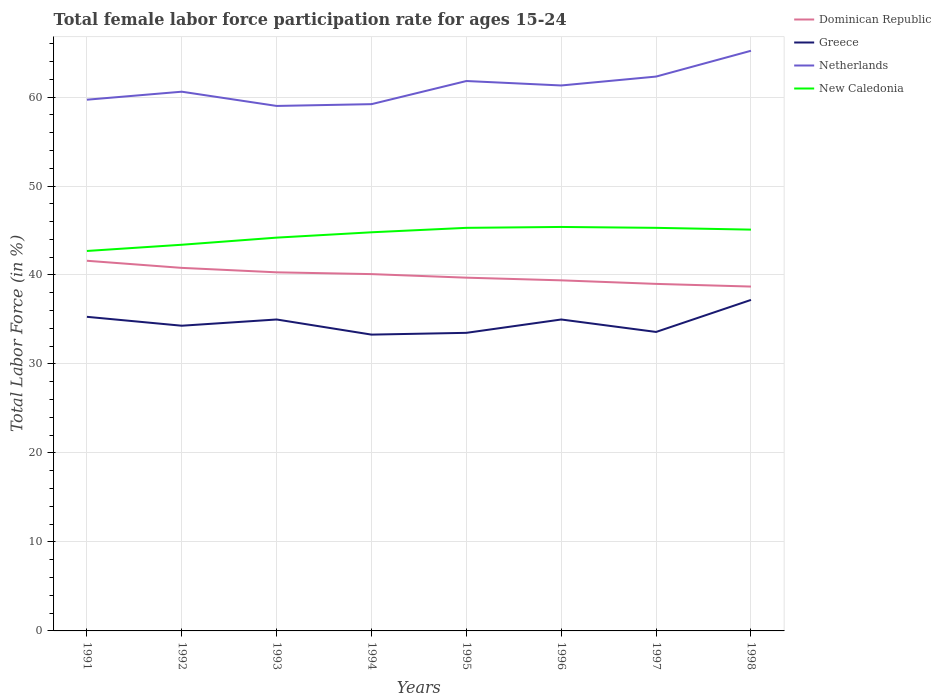How many different coloured lines are there?
Your answer should be very brief. 4. Does the line corresponding to New Caledonia intersect with the line corresponding to Netherlands?
Provide a short and direct response. No. Is the number of lines equal to the number of legend labels?
Provide a succinct answer. Yes. Across all years, what is the maximum female labor force participation rate in Greece?
Give a very brief answer. 33.3. In which year was the female labor force participation rate in New Caledonia maximum?
Give a very brief answer. 1991. What is the total female labor force participation rate in Greece in the graph?
Provide a succinct answer. -3.7. What is the difference between the highest and the second highest female labor force participation rate in Netherlands?
Your answer should be compact. 6.2. What is the difference between the highest and the lowest female labor force participation rate in New Caledonia?
Your answer should be compact. 5. Is the female labor force participation rate in Greece strictly greater than the female labor force participation rate in Netherlands over the years?
Give a very brief answer. Yes. How many lines are there?
Provide a succinct answer. 4. How many years are there in the graph?
Ensure brevity in your answer.  8. How many legend labels are there?
Your response must be concise. 4. How are the legend labels stacked?
Your answer should be compact. Vertical. What is the title of the graph?
Ensure brevity in your answer.  Total female labor force participation rate for ages 15-24. Does "Grenada" appear as one of the legend labels in the graph?
Your response must be concise. No. What is the Total Labor Force (in %) of Dominican Republic in 1991?
Your answer should be compact. 41.6. What is the Total Labor Force (in %) of Greece in 1991?
Keep it short and to the point. 35.3. What is the Total Labor Force (in %) in Netherlands in 1991?
Provide a succinct answer. 59.7. What is the Total Labor Force (in %) of New Caledonia in 1991?
Your response must be concise. 42.7. What is the Total Labor Force (in %) of Dominican Republic in 1992?
Your answer should be compact. 40.8. What is the Total Labor Force (in %) of Greece in 1992?
Offer a terse response. 34.3. What is the Total Labor Force (in %) in Netherlands in 1992?
Give a very brief answer. 60.6. What is the Total Labor Force (in %) in New Caledonia in 1992?
Your answer should be very brief. 43.4. What is the Total Labor Force (in %) of Dominican Republic in 1993?
Your response must be concise. 40.3. What is the Total Labor Force (in %) of Greece in 1993?
Give a very brief answer. 35. What is the Total Labor Force (in %) in Netherlands in 1993?
Provide a short and direct response. 59. What is the Total Labor Force (in %) in New Caledonia in 1993?
Provide a succinct answer. 44.2. What is the Total Labor Force (in %) in Dominican Republic in 1994?
Provide a short and direct response. 40.1. What is the Total Labor Force (in %) in Greece in 1994?
Ensure brevity in your answer.  33.3. What is the Total Labor Force (in %) in Netherlands in 1994?
Make the answer very short. 59.2. What is the Total Labor Force (in %) in New Caledonia in 1994?
Provide a succinct answer. 44.8. What is the Total Labor Force (in %) in Dominican Republic in 1995?
Your answer should be compact. 39.7. What is the Total Labor Force (in %) of Greece in 1995?
Offer a terse response. 33.5. What is the Total Labor Force (in %) in Netherlands in 1995?
Offer a very short reply. 61.8. What is the Total Labor Force (in %) in New Caledonia in 1995?
Your answer should be compact. 45.3. What is the Total Labor Force (in %) in Dominican Republic in 1996?
Provide a succinct answer. 39.4. What is the Total Labor Force (in %) of Greece in 1996?
Your answer should be very brief. 35. What is the Total Labor Force (in %) in Netherlands in 1996?
Offer a very short reply. 61.3. What is the Total Labor Force (in %) in New Caledonia in 1996?
Ensure brevity in your answer.  45.4. What is the Total Labor Force (in %) of Dominican Republic in 1997?
Offer a very short reply. 39. What is the Total Labor Force (in %) in Greece in 1997?
Ensure brevity in your answer.  33.6. What is the Total Labor Force (in %) of Netherlands in 1997?
Give a very brief answer. 62.3. What is the Total Labor Force (in %) of New Caledonia in 1997?
Ensure brevity in your answer.  45.3. What is the Total Labor Force (in %) of Dominican Republic in 1998?
Your response must be concise. 38.7. What is the Total Labor Force (in %) in Greece in 1998?
Make the answer very short. 37.2. What is the Total Labor Force (in %) in Netherlands in 1998?
Keep it short and to the point. 65.2. What is the Total Labor Force (in %) in New Caledonia in 1998?
Provide a short and direct response. 45.1. Across all years, what is the maximum Total Labor Force (in %) of Dominican Republic?
Your answer should be compact. 41.6. Across all years, what is the maximum Total Labor Force (in %) in Greece?
Provide a succinct answer. 37.2. Across all years, what is the maximum Total Labor Force (in %) in Netherlands?
Provide a short and direct response. 65.2. Across all years, what is the maximum Total Labor Force (in %) in New Caledonia?
Provide a short and direct response. 45.4. Across all years, what is the minimum Total Labor Force (in %) of Dominican Republic?
Give a very brief answer. 38.7. Across all years, what is the minimum Total Labor Force (in %) of Greece?
Ensure brevity in your answer.  33.3. Across all years, what is the minimum Total Labor Force (in %) of New Caledonia?
Keep it short and to the point. 42.7. What is the total Total Labor Force (in %) in Dominican Republic in the graph?
Provide a short and direct response. 319.6. What is the total Total Labor Force (in %) in Greece in the graph?
Give a very brief answer. 277.2. What is the total Total Labor Force (in %) in Netherlands in the graph?
Your answer should be compact. 489.1. What is the total Total Labor Force (in %) of New Caledonia in the graph?
Provide a short and direct response. 356.2. What is the difference between the Total Labor Force (in %) in New Caledonia in 1991 and that in 1992?
Your answer should be very brief. -0.7. What is the difference between the Total Labor Force (in %) of Dominican Republic in 1991 and that in 1993?
Your answer should be compact. 1.3. What is the difference between the Total Labor Force (in %) in Dominican Republic in 1991 and that in 1994?
Your answer should be very brief. 1.5. What is the difference between the Total Labor Force (in %) in Netherlands in 1991 and that in 1994?
Your response must be concise. 0.5. What is the difference between the Total Labor Force (in %) in Dominican Republic in 1991 and that in 1995?
Give a very brief answer. 1.9. What is the difference between the Total Labor Force (in %) of Dominican Republic in 1991 and that in 1997?
Provide a succinct answer. 2.6. What is the difference between the Total Labor Force (in %) of Dominican Republic in 1991 and that in 1998?
Ensure brevity in your answer.  2.9. What is the difference between the Total Labor Force (in %) in Greece in 1992 and that in 1994?
Your answer should be very brief. 1. What is the difference between the Total Labor Force (in %) in Netherlands in 1992 and that in 1994?
Make the answer very short. 1.4. What is the difference between the Total Labor Force (in %) in Dominican Republic in 1992 and that in 1995?
Make the answer very short. 1.1. What is the difference between the Total Labor Force (in %) in Netherlands in 1992 and that in 1995?
Offer a terse response. -1.2. What is the difference between the Total Labor Force (in %) in New Caledonia in 1992 and that in 1995?
Make the answer very short. -1.9. What is the difference between the Total Labor Force (in %) in Greece in 1992 and that in 1996?
Keep it short and to the point. -0.7. What is the difference between the Total Labor Force (in %) of New Caledonia in 1992 and that in 1996?
Your answer should be compact. -2. What is the difference between the Total Labor Force (in %) in Dominican Republic in 1992 and that in 1997?
Your response must be concise. 1.8. What is the difference between the Total Labor Force (in %) of Greece in 1992 and that in 1997?
Offer a very short reply. 0.7. What is the difference between the Total Labor Force (in %) of Netherlands in 1992 and that in 1997?
Offer a very short reply. -1.7. What is the difference between the Total Labor Force (in %) in New Caledonia in 1992 and that in 1997?
Your answer should be very brief. -1.9. What is the difference between the Total Labor Force (in %) in Dominican Republic in 1992 and that in 1998?
Provide a short and direct response. 2.1. What is the difference between the Total Labor Force (in %) of Greece in 1993 and that in 1994?
Your answer should be compact. 1.7. What is the difference between the Total Labor Force (in %) of New Caledonia in 1993 and that in 1994?
Provide a succinct answer. -0.6. What is the difference between the Total Labor Force (in %) in Dominican Republic in 1993 and that in 1995?
Provide a succinct answer. 0.6. What is the difference between the Total Labor Force (in %) of Netherlands in 1993 and that in 1995?
Give a very brief answer. -2.8. What is the difference between the Total Labor Force (in %) in New Caledonia in 1993 and that in 1995?
Offer a terse response. -1.1. What is the difference between the Total Labor Force (in %) of Greece in 1993 and that in 1997?
Your answer should be compact. 1.4. What is the difference between the Total Labor Force (in %) in Netherlands in 1993 and that in 1997?
Ensure brevity in your answer.  -3.3. What is the difference between the Total Labor Force (in %) in New Caledonia in 1993 and that in 1997?
Make the answer very short. -1.1. What is the difference between the Total Labor Force (in %) of New Caledonia in 1993 and that in 1998?
Your answer should be compact. -0.9. What is the difference between the Total Labor Force (in %) in Greece in 1994 and that in 1995?
Give a very brief answer. -0.2. What is the difference between the Total Labor Force (in %) in Greece in 1994 and that in 1996?
Your response must be concise. -1.7. What is the difference between the Total Labor Force (in %) in New Caledonia in 1994 and that in 1996?
Your answer should be compact. -0.6. What is the difference between the Total Labor Force (in %) in Greece in 1994 and that in 1997?
Your answer should be compact. -0.3. What is the difference between the Total Labor Force (in %) of New Caledonia in 1994 and that in 1997?
Your response must be concise. -0.5. What is the difference between the Total Labor Force (in %) of Greece in 1994 and that in 1998?
Make the answer very short. -3.9. What is the difference between the Total Labor Force (in %) in Netherlands in 1994 and that in 1998?
Keep it short and to the point. -6. What is the difference between the Total Labor Force (in %) in Greece in 1995 and that in 1996?
Provide a succinct answer. -1.5. What is the difference between the Total Labor Force (in %) of Dominican Republic in 1995 and that in 1997?
Your response must be concise. 0.7. What is the difference between the Total Labor Force (in %) in Netherlands in 1995 and that in 1997?
Your answer should be compact. -0.5. What is the difference between the Total Labor Force (in %) of New Caledonia in 1995 and that in 1997?
Give a very brief answer. 0. What is the difference between the Total Labor Force (in %) of New Caledonia in 1995 and that in 1998?
Offer a very short reply. 0.2. What is the difference between the Total Labor Force (in %) of Dominican Republic in 1996 and that in 1997?
Your answer should be very brief. 0.4. What is the difference between the Total Labor Force (in %) in Netherlands in 1996 and that in 1997?
Provide a succinct answer. -1. What is the difference between the Total Labor Force (in %) of Greece in 1996 and that in 1998?
Offer a terse response. -2.2. What is the difference between the Total Labor Force (in %) in Netherlands in 1996 and that in 1998?
Offer a very short reply. -3.9. What is the difference between the Total Labor Force (in %) of New Caledonia in 1996 and that in 1998?
Make the answer very short. 0.3. What is the difference between the Total Labor Force (in %) of Greece in 1997 and that in 1998?
Offer a terse response. -3.6. What is the difference between the Total Labor Force (in %) in Greece in 1991 and the Total Labor Force (in %) in Netherlands in 1992?
Your answer should be compact. -25.3. What is the difference between the Total Labor Force (in %) in Dominican Republic in 1991 and the Total Labor Force (in %) in Netherlands in 1993?
Your response must be concise. -17.4. What is the difference between the Total Labor Force (in %) in Greece in 1991 and the Total Labor Force (in %) in Netherlands in 1993?
Your answer should be very brief. -23.7. What is the difference between the Total Labor Force (in %) of Greece in 1991 and the Total Labor Force (in %) of New Caledonia in 1993?
Offer a terse response. -8.9. What is the difference between the Total Labor Force (in %) in Netherlands in 1991 and the Total Labor Force (in %) in New Caledonia in 1993?
Give a very brief answer. 15.5. What is the difference between the Total Labor Force (in %) of Dominican Republic in 1991 and the Total Labor Force (in %) of Greece in 1994?
Keep it short and to the point. 8.3. What is the difference between the Total Labor Force (in %) of Dominican Republic in 1991 and the Total Labor Force (in %) of Netherlands in 1994?
Offer a very short reply. -17.6. What is the difference between the Total Labor Force (in %) in Dominican Republic in 1991 and the Total Labor Force (in %) in New Caledonia in 1994?
Provide a short and direct response. -3.2. What is the difference between the Total Labor Force (in %) of Greece in 1991 and the Total Labor Force (in %) of Netherlands in 1994?
Provide a succinct answer. -23.9. What is the difference between the Total Labor Force (in %) of Netherlands in 1991 and the Total Labor Force (in %) of New Caledonia in 1994?
Provide a short and direct response. 14.9. What is the difference between the Total Labor Force (in %) in Dominican Republic in 1991 and the Total Labor Force (in %) in Netherlands in 1995?
Offer a very short reply. -20.2. What is the difference between the Total Labor Force (in %) of Greece in 1991 and the Total Labor Force (in %) of Netherlands in 1995?
Your answer should be very brief. -26.5. What is the difference between the Total Labor Force (in %) of Netherlands in 1991 and the Total Labor Force (in %) of New Caledonia in 1995?
Make the answer very short. 14.4. What is the difference between the Total Labor Force (in %) of Dominican Republic in 1991 and the Total Labor Force (in %) of Greece in 1996?
Ensure brevity in your answer.  6.6. What is the difference between the Total Labor Force (in %) in Dominican Republic in 1991 and the Total Labor Force (in %) in Netherlands in 1996?
Give a very brief answer. -19.7. What is the difference between the Total Labor Force (in %) of Greece in 1991 and the Total Labor Force (in %) of Netherlands in 1996?
Make the answer very short. -26. What is the difference between the Total Labor Force (in %) in Dominican Republic in 1991 and the Total Labor Force (in %) in Greece in 1997?
Your answer should be very brief. 8. What is the difference between the Total Labor Force (in %) of Dominican Republic in 1991 and the Total Labor Force (in %) of Netherlands in 1997?
Keep it short and to the point. -20.7. What is the difference between the Total Labor Force (in %) in Greece in 1991 and the Total Labor Force (in %) in Netherlands in 1997?
Provide a succinct answer. -27. What is the difference between the Total Labor Force (in %) of Greece in 1991 and the Total Labor Force (in %) of New Caledonia in 1997?
Make the answer very short. -10. What is the difference between the Total Labor Force (in %) in Netherlands in 1991 and the Total Labor Force (in %) in New Caledonia in 1997?
Your answer should be compact. 14.4. What is the difference between the Total Labor Force (in %) of Dominican Republic in 1991 and the Total Labor Force (in %) of Netherlands in 1998?
Keep it short and to the point. -23.6. What is the difference between the Total Labor Force (in %) in Dominican Republic in 1991 and the Total Labor Force (in %) in New Caledonia in 1998?
Provide a short and direct response. -3.5. What is the difference between the Total Labor Force (in %) in Greece in 1991 and the Total Labor Force (in %) in Netherlands in 1998?
Provide a succinct answer. -29.9. What is the difference between the Total Labor Force (in %) of Greece in 1991 and the Total Labor Force (in %) of New Caledonia in 1998?
Offer a terse response. -9.8. What is the difference between the Total Labor Force (in %) of Dominican Republic in 1992 and the Total Labor Force (in %) of Greece in 1993?
Keep it short and to the point. 5.8. What is the difference between the Total Labor Force (in %) of Dominican Republic in 1992 and the Total Labor Force (in %) of Netherlands in 1993?
Your answer should be very brief. -18.2. What is the difference between the Total Labor Force (in %) in Dominican Republic in 1992 and the Total Labor Force (in %) in New Caledonia in 1993?
Keep it short and to the point. -3.4. What is the difference between the Total Labor Force (in %) of Greece in 1992 and the Total Labor Force (in %) of Netherlands in 1993?
Offer a terse response. -24.7. What is the difference between the Total Labor Force (in %) in Dominican Republic in 1992 and the Total Labor Force (in %) in Netherlands in 1994?
Give a very brief answer. -18.4. What is the difference between the Total Labor Force (in %) in Dominican Republic in 1992 and the Total Labor Force (in %) in New Caledonia in 1994?
Provide a short and direct response. -4. What is the difference between the Total Labor Force (in %) of Greece in 1992 and the Total Labor Force (in %) of Netherlands in 1994?
Give a very brief answer. -24.9. What is the difference between the Total Labor Force (in %) in Greece in 1992 and the Total Labor Force (in %) in New Caledonia in 1994?
Ensure brevity in your answer.  -10.5. What is the difference between the Total Labor Force (in %) of Dominican Republic in 1992 and the Total Labor Force (in %) of Netherlands in 1995?
Ensure brevity in your answer.  -21. What is the difference between the Total Labor Force (in %) of Greece in 1992 and the Total Labor Force (in %) of Netherlands in 1995?
Offer a terse response. -27.5. What is the difference between the Total Labor Force (in %) in Dominican Republic in 1992 and the Total Labor Force (in %) in Netherlands in 1996?
Make the answer very short. -20.5. What is the difference between the Total Labor Force (in %) in Greece in 1992 and the Total Labor Force (in %) in Netherlands in 1996?
Make the answer very short. -27. What is the difference between the Total Labor Force (in %) in Netherlands in 1992 and the Total Labor Force (in %) in New Caledonia in 1996?
Your response must be concise. 15.2. What is the difference between the Total Labor Force (in %) in Dominican Republic in 1992 and the Total Labor Force (in %) in Netherlands in 1997?
Offer a terse response. -21.5. What is the difference between the Total Labor Force (in %) of Greece in 1992 and the Total Labor Force (in %) of New Caledonia in 1997?
Give a very brief answer. -11. What is the difference between the Total Labor Force (in %) of Dominican Republic in 1992 and the Total Labor Force (in %) of Greece in 1998?
Ensure brevity in your answer.  3.6. What is the difference between the Total Labor Force (in %) in Dominican Republic in 1992 and the Total Labor Force (in %) in Netherlands in 1998?
Your answer should be compact. -24.4. What is the difference between the Total Labor Force (in %) of Dominican Republic in 1992 and the Total Labor Force (in %) of New Caledonia in 1998?
Provide a short and direct response. -4.3. What is the difference between the Total Labor Force (in %) of Greece in 1992 and the Total Labor Force (in %) of Netherlands in 1998?
Your answer should be very brief. -30.9. What is the difference between the Total Labor Force (in %) of Netherlands in 1992 and the Total Labor Force (in %) of New Caledonia in 1998?
Your answer should be very brief. 15.5. What is the difference between the Total Labor Force (in %) in Dominican Republic in 1993 and the Total Labor Force (in %) in Netherlands in 1994?
Offer a terse response. -18.9. What is the difference between the Total Labor Force (in %) of Greece in 1993 and the Total Labor Force (in %) of Netherlands in 1994?
Your answer should be compact. -24.2. What is the difference between the Total Labor Force (in %) of Netherlands in 1993 and the Total Labor Force (in %) of New Caledonia in 1994?
Offer a very short reply. 14.2. What is the difference between the Total Labor Force (in %) in Dominican Republic in 1993 and the Total Labor Force (in %) in Greece in 1995?
Offer a terse response. 6.8. What is the difference between the Total Labor Force (in %) in Dominican Republic in 1993 and the Total Labor Force (in %) in Netherlands in 1995?
Ensure brevity in your answer.  -21.5. What is the difference between the Total Labor Force (in %) in Greece in 1993 and the Total Labor Force (in %) in Netherlands in 1995?
Offer a terse response. -26.8. What is the difference between the Total Labor Force (in %) in Greece in 1993 and the Total Labor Force (in %) in New Caledonia in 1995?
Offer a very short reply. -10.3. What is the difference between the Total Labor Force (in %) in Dominican Republic in 1993 and the Total Labor Force (in %) in Netherlands in 1996?
Provide a succinct answer. -21. What is the difference between the Total Labor Force (in %) of Greece in 1993 and the Total Labor Force (in %) of Netherlands in 1996?
Keep it short and to the point. -26.3. What is the difference between the Total Labor Force (in %) in Netherlands in 1993 and the Total Labor Force (in %) in New Caledonia in 1996?
Offer a terse response. 13.6. What is the difference between the Total Labor Force (in %) of Dominican Republic in 1993 and the Total Labor Force (in %) of Netherlands in 1997?
Offer a very short reply. -22. What is the difference between the Total Labor Force (in %) in Dominican Republic in 1993 and the Total Labor Force (in %) in New Caledonia in 1997?
Make the answer very short. -5. What is the difference between the Total Labor Force (in %) in Greece in 1993 and the Total Labor Force (in %) in Netherlands in 1997?
Offer a very short reply. -27.3. What is the difference between the Total Labor Force (in %) in Greece in 1993 and the Total Labor Force (in %) in New Caledonia in 1997?
Provide a succinct answer. -10.3. What is the difference between the Total Labor Force (in %) in Dominican Republic in 1993 and the Total Labor Force (in %) in Greece in 1998?
Keep it short and to the point. 3.1. What is the difference between the Total Labor Force (in %) in Dominican Republic in 1993 and the Total Labor Force (in %) in Netherlands in 1998?
Provide a short and direct response. -24.9. What is the difference between the Total Labor Force (in %) in Greece in 1993 and the Total Labor Force (in %) in Netherlands in 1998?
Your answer should be very brief. -30.2. What is the difference between the Total Labor Force (in %) of Dominican Republic in 1994 and the Total Labor Force (in %) of Greece in 1995?
Your answer should be very brief. 6.6. What is the difference between the Total Labor Force (in %) in Dominican Republic in 1994 and the Total Labor Force (in %) in Netherlands in 1995?
Provide a succinct answer. -21.7. What is the difference between the Total Labor Force (in %) in Dominican Republic in 1994 and the Total Labor Force (in %) in New Caledonia in 1995?
Ensure brevity in your answer.  -5.2. What is the difference between the Total Labor Force (in %) in Greece in 1994 and the Total Labor Force (in %) in Netherlands in 1995?
Provide a succinct answer. -28.5. What is the difference between the Total Labor Force (in %) in Greece in 1994 and the Total Labor Force (in %) in New Caledonia in 1995?
Ensure brevity in your answer.  -12. What is the difference between the Total Labor Force (in %) in Netherlands in 1994 and the Total Labor Force (in %) in New Caledonia in 1995?
Ensure brevity in your answer.  13.9. What is the difference between the Total Labor Force (in %) of Dominican Republic in 1994 and the Total Labor Force (in %) of Netherlands in 1996?
Ensure brevity in your answer.  -21.2. What is the difference between the Total Labor Force (in %) of Greece in 1994 and the Total Labor Force (in %) of New Caledonia in 1996?
Ensure brevity in your answer.  -12.1. What is the difference between the Total Labor Force (in %) in Netherlands in 1994 and the Total Labor Force (in %) in New Caledonia in 1996?
Give a very brief answer. 13.8. What is the difference between the Total Labor Force (in %) of Dominican Republic in 1994 and the Total Labor Force (in %) of Netherlands in 1997?
Offer a terse response. -22.2. What is the difference between the Total Labor Force (in %) of Greece in 1994 and the Total Labor Force (in %) of New Caledonia in 1997?
Your answer should be compact. -12. What is the difference between the Total Labor Force (in %) in Dominican Republic in 1994 and the Total Labor Force (in %) in Netherlands in 1998?
Your response must be concise. -25.1. What is the difference between the Total Labor Force (in %) in Greece in 1994 and the Total Labor Force (in %) in Netherlands in 1998?
Keep it short and to the point. -31.9. What is the difference between the Total Labor Force (in %) of Greece in 1994 and the Total Labor Force (in %) of New Caledonia in 1998?
Give a very brief answer. -11.8. What is the difference between the Total Labor Force (in %) of Dominican Republic in 1995 and the Total Labor Force (in %) of Greece in 1996?
Offer a very short reply. 4.7. What is the difference between the Total Labor Force (in %) in Dominican Republic in 1995 and the Total Labor Force (in %) in Netherlands in 1996?
Your answer should be very brief. -21.6. What is the difference between the Total Labor Force (in %) of Greece in 1995 and the Total Labor Force (in %) of Netherlands in 1996?
Ensure brevity in your answer.  -27.8. What is the difference between the Total Labor Force (in %) of Dominican Republic in 1995 and the Total Labor Force (in %) of Greece in 1997?
Your answer should be very brief. 6.1. What is the difference between the Total Labor Force (in %) of Dominican Republic in 1995 and the Total Labor Force (in %) of Netherlands in 1997?
Offer a very short reply. -22.6. What is the difference between the Total Labor Force (in %) in Greece in 1995 and the Total Labor Force (in %) in Netherlands in 1997?
Provide a succinct answer. -28.8. What is the difference between the Total Labor Force (in %) in Netherlands in 1995 and the Total Labor Force (in %) in New Caledonia in 1997?
Keep it short and to the point. 16.5. What is the difference between the Total Labor Force (in %) in Dominican Republic in 1995 and the Total Labor Force (in %) in Netherlands in 1998?
Ensure brevity in your answer.  -25.5. What is the difference between the Total Labor Force (in %) in Dominican Republic in 1995 and the Total Labor Force (in %) in New Caledonia in 1998?
Keep it short and to the point. -5.4. What is the difference between the Total Labor Force (in %) in Greece in 1995 and the Total Labor Force (in %) in Netherlands in 1998?
Keep it short and to the point. -31.7. What is the difference between the Total Labor Force (in %) in Dominican Republic in 1996 and the Total Labor Force (in %) in Greece in 1997?
Provide a succinct answer. 5.8. What is the difference between the Total Labor Force (in %) of Dominican Republic in 1996 and the Total Labor Force (in %) of Netherlands in 1997?
Offer a terse response. -22.9. What is the difference between the Total Labor Force (in %) in Dominican Republic in 1996 and the Total Labor Force (in %) in New Caledonia in 1997?
Offer a very short reply. -5.9. What is the difference between the Total Labor Force (in %) of Greece in 1996 and the Total Labor Force (in %) of Netherlands in 1997?
Offer a terse response. -27.3. What is the difference between the Total Labor Force (in %) of Greece in 1996 and the Total Labor Force (in %) of New Caledonia in 1997?
Ensure brevity in your answer.  -10.3. What is the difference between the Total Labor Force (in %) of Dominican Republic in 1996 and the Total Labor Force (in %) of Netherlands in 1998?
Ensure brevity in your answer.  -25.8. What is the difference between the Total Labor Force (in %) of Dominican Republic in 1996 and the Total Labor Force (in %) of New Caledonia in 1998?
Make the answer very short. -5.7. What is the difference between the Total Labor Force (in %) in Greece in 1996 and the Total Labor Force (in %) in Netherlands in 1998?
Provide a short and direct response. -30.2. What is the difference between the Total Labor Force (in %) of Dominican Republic in 1997 and the Total Labor Force (in %) of Netherlands in 1998?
Give a very brief answer. -26.2. What is the difference between the Total Labor Force (in %) in Dominican Republic in 1997 and the Total Labor Force (in %) in New Caledonia in 1998?
Ensure brevity in your answer.  -6.1. What is the difference between the Total Labor Force (in %) of Greece in 1997 and the Total Labor Force (in %) of Netherlands in 1998?
Your answer should be compact. -31.6. What is the difference between the Total Labor Force (in %) of Greece in 1997 and the Total Labor Force (in %) of New Caledonia in 1998?
Your response must be concise. -11.5. What is the difference between the Total Labor Force (in %) in Netherlands in 1997 and the Total Labor Force (in %) in New Caledonia in 1998?
Keep it short and to the point. 17.2. What is the average Total Labor Force (in %) in Dominican Republic per year?
Provide a short and direct response. 39.95. What is the average Total Labor Force (in %) in Greece per year?
Offer a very short reply. 34.65. What is the average Total Labor Force (in %) of Netherlands per year?
Your answer should be compact. 61.14. What is the average Total Labor Force (in %) in New Caledonia per year?
Ensure brevity in your answer.  44.52. In the year 1991, what is the difference between the Total Labor Force (in %) of Dominican Republic and Total Labor Force (in %) of Netherlands?
Make the answer very short. -18.1. In the year 1991, what is the difference between the Total Labor Force (in %) of Greece and Total Labor Force (in %) of Netherlands?
Offer a terse response. -24.4. In the year 1991, what is the difference between the Total Labor Force (in %) of Greece and Total Labor Force (in %) of New Caledonia?
Provide a short and direct response. -7.4. In the year 1991, what is the difference between the Total Labor Force (in %) in Netherlands and Total Labor Force (in %) in New Caledonia?
Provide a succinct answer. 17. In the year 1992, what is the difference between the Total Labor Force (in %) in Dominican Republic and Total Labor Force (in %) in Netherlands?
Your answer should be very brief. -19.8. In the year 1992, what is the difference between the Total Labor Force (in %) of Dominican Republic and Total Labor Force (in %) of New Caledonia?
Your answer should be compact. -2.6. In the year 1992, what is the difference between the Total Labor Force (in %) of Greece and Total Labor Force (in %) of Netherlands?
Keep it short and to the point. -26.3. In the year 1992, what is the difference between the Total Labor Force (in %) of Netherlands and Total Labor Force (in %) of New Caledonia?
Make the answer very short. 17.2. In the year 1993, what is the difference between the Total Labor Force (in %) of Dominican Republic and Total Labor Force (in %) of Greece?
Give a very brief answer. 5.3. In the year 1993, what is the difference between the Total Labor Force (in %) in Dominican Republic and Total Labor Force (in %) in Netherlands?
Keep it short and to the point. -18.7. In the year 1993, what is the difference between the Total Labor Force (in %) of Dominican Republic and Total Labor Force (in %) of New Caledonia?
Offer a terse response. -3.9. In the year 1993, what is the difference between the Total Labor Force (in %) in Netherlands and Total Labor Force (in %) in New Caledonia?
Ensure brevity in your answer.  14.8. In the year 1994, what is the difference between the Total Labor Force (in %) of Dominican Republic and Total Labor Force (in %) of Greece?
Ensure brevity in your answer.  6.8. In the year 1994, what is the difference between the Total Labor Force (in %) in Dominican Republic and Total Labor Force (in %) in Netherlands?
Make the answer very short. -19.1. In the year 1994, what is the difference between the Total Labor Force (in %) of Dominican Republic and Total Labor Force (in %) of New Caledonia?
Keep it short and to the point. -4.7. In the year 1994, what is the difference between the Total Labor Force (in %) in Greece and Total Labor Force (in %) in Netherlands?
Provide a short and direct response. -25.9. In the year 1994, what is the difference between the Total Labor Force (in %) of Greece and Total Labor Force (in %) of New Caledonia?
Provide a short and direct response. -11.5. In the year 1994, what is the difference between the Total Labor Force (in %) in Netherlands and Total Labor Force (in %) in New Caledonia?
Keep it short and to the point. 14.4. In the year 1995, what is the difference between the Total Labor Force (in %) in Dominican Republic and Total Labor Force (in %) in Netherlands?
Offer a terse response. -22.1. In the year 1995, what is the difference between the Total Labor Force (in %) of Dominican Republic and Total Labor Force (in %) of New Caledonia?
Your response must be concise. -5.6. In the year 1995, what is the difference between the Total Labor Force (in %) in Greece and Total Labor Force (in %) in Netherlands?
Make the answer very short. -28.3. In the year 1995, what is the difference between the Total Labor Force (in %) of Greece and Total Labor Force (in %) of New Caledonia?
Your answer should be compact. -11.8. In the year 1996, what is the difference between the Total Labor Force (in %) of Dominican Republic and Total Labor Force (in %) of Greece?
Provide a short and direct response. 4.4. In the year 1996, what is the difference between the Total Labor Force (in %) of Dominican Republic and Total Labor Force (in %) of Netherlands?
Ensure brevity in your answer.  -21.9. In the year 1996, what is the difference between the Total Labor Force (in %) in Greece and Total Labor Force (in %) in Netherlands?
Give a very brief answer. -26.3. In the year 1997, what is the difference between the Total Labor Force (in %) in Dominican Republic and Total Labor Force (in %) in Greece?
Provide a short and direct response. 5.4. In the year 1997, what is the difference between the Total Labor Force (in %) in Dominican Republic and Total Labor Force (in %) in Netherlands?
Make the answer very short. -23.3. In the year 1997, what is the difference between the Total Labor Force (in %) in Greece and Total Labor Force (in %) in Netherlands?
Give a very brief answer. -28.7. In the year 1998, what is the difference between the Total Labor Force (in %) of Dominican Republic and Total Labor Force (in %) of Netherlands?
Provide a short and direct response. -26.5. In the year 1998, what is the difference between the Total Labor Force (in %) in Greece and Total Labor Force (in %) in Netherlands?
Make the answer very short. -28. In the year 1998, what is the difference between the Total Labor Force (in %) in Greece and Total Labor Force (in %) in New Caledonia?
Offer a terse response. -7.9. In the year 1998, what is the difference between the Total Labor Force (in %) of Netherlands and Total Labor Force (in %) of New Caledonia?
Offer a terse response. 20.1. What is the ratio of the Total Labor Force (in %) in Dominican Republic in 1991 to that in 1992?
Offer a terse response. 1.02. What is the ratio of the Total Labor Force (in %) of Greece in 1991 to that in 1992?
Provide a short and direct response. 1.03. What is the ratio of the Total Labor Force (in %) of Netherlands in 1991 to that in 1992?
Your answer should be very brief. 0.99. What is the ratio of the Total Labor Force (in %) of New Caledonia in 1991 to that in 1992?
Your answer should be very brief. 0.98. What is the ratio of the Total Labor Force (in %) in Dominican Republic in 1991 to that in 1993?
Your answer should be very brief. 1.03. What is the ratio of the Total Labor Force (in %) in Greece in 1991 to that in 1993?
Offer a terse response. 1.01. What is the ratio of the Total Labor Force (in %) of Netherlands in 1991 to that in 1993?
Your response must be concise. 1.01. What is the ratio of the Total Labor Force (in %) in New Caledonia in 1991 to that in 1993?
Provide a succinct answer. 0.97. What is the ratio of the Total Labor Force (in %) in Dominican Republic in 1991 to that in 1994?
Give a very brief answer. 1.04. What is the ratio of the Total Labor Force (in %) in Greece in 1991 to that in 1994?
Provide a short and direct response. 1.06. What is the ratio of the Total Labor Force (in %) in Netherlands in 1991 to that in 1994?
Provide a succinct answer. 1.01. What is the ratio of the Total Labor Force (in %) in New Caledonia in 1991 to that in 1994?
Give a very brief answer. 0.95. What is the ratio of the Total Labor Force (in %) of Dominican Republic in 1991 to that in 1995?
Your answer should be compact. 1.05. What is the ratio of the Total Labor Force (in %) in Greece in 1991 to that in 1995?
Your answer should be very brief. 1.05. What is the ratio of the Total Labor Force (in %) of New Caledonia in 1991 to that in 1995?
Give a very brief answer. 0.94. What is the ratio of the Total Labor Force (in %) in Dominican Republic in 1991 to that in 1996?
Your response must be concise. 1.06. What is the ratio of the Total Labor Force (in %) of Greece in 1991 to that in 1996?
Your answer should be compact. 1.01. What is the ratio of the Total Labor Force (in %) of Netherlands in 1991 to that in 1996?
Provide a short and direct response. 0.97. What is the ratio of the Total Labor Force (in %) in New Caledonia in 1991 to that in 1996?
Your answer should be compact. 0.94. What is the ratio of the Total Labor Force (in %) in Dominican Republic in 1991 to that in 1997?
Your answer should be very brief. 1.07. What is the ratio of the Total Labor Force (in %) of Greece in 1991 to that in 1997?
Offer a very short reply. 1.05. What is the ratio of the Total Labor Force (in %) in Netherlands in 1991 to that in 1997?
Ensure brevity in your answer.  0.96. What is the ratio of the Total Labor Force (in %) in New Caledonia in 1991 to that in 1997?
Offer a very short reply. 0.94. What is the ratio of the Total Labor Force (in %) in Dominican Republic in 1991 to that in 1998?
Offer a terse response. 1.07. What is the ratio of the Total Labor Force (in %) in Greece in 1991 to that in 1998?
Provide a short and direct response. 0.95. What is the ratio of the Total Labor Force (in %) of Netherlands in 1991 to that in 1998?
Keep it short and to the point. 0.92. What is the ratio of the Total Labor Force (in %) in New Caledonia in 1991 to that in 1998?
Provide a short and direct response. 0.95. What is the ratio of the Total Labor Force (in %) of Dominican Republic in 1992 to that in 1993?
Give a very brief answer. 1.01. What is the ratio of the Total Labor Force (in %) in Greece in 1992 to that in 1993?
Offer a very short reply. 0.98. What is the ratio of the Total Labor Force (in %) of Netherlands in 1992 to that in 1993?
Ensure brevity in your answer.  1.03. What is the ratio of the Total Labor Force (in %) of New Caledonia in 1992 to that in 1993?
Ensure brevity in your answer.  0.98. What is the ratio of the Total Labor Force (in %) of Dominican Republic in 1992 to that in 1994?
Make the answer very short. 1.02. What is the ratio of the Total Labor Force (in %) of Netherlands in 1992 to that in 1994?
Your response must be concise. 1.02. What is the ratio of the Total Labor Force (in %) of New Caledonia in 1992 to that in 1994?
Ensure brevity in your answer.  0.97. What is the ratio of the Total Labor Force (in %) in Dominican Republic in 1992 to that in 1995?
Keep it short and to the point. 1.03. What is the ratio of the Total Labor Force (in %) of Greece in 1992 to that in 1995?
Give a very brief answer. 1.02. What is the ratio of the Total Labor Force (in %) in Netherlands in 1992 to that in 1995?
Keep it short and to the point. 0.98. What is the ratio of the Total Labor Force (in %) of New Caledonia in 1992 to that in 1995?
Give a very brief answer. 0.96. What is the ratio of the Total Labor Force (in %) in Dominican Republic in 1992 to that in 1996?
Provide a succinct answer. 1.04. What is the ratio of the Total Labor Force (in %) in New Caledonia in 1992 to that in 1996?
Your response must be concise. 0.96. What is the ratio of the Total Labor Force (in %) of Dominican Republic in 1992 to that in 1997?
Make the answer very short. 1.05. What is the ratio of the Total Labor Force (in %) in Greece in 1992 to that in 1997?
Offer a very short reply. 1.02. What is the ratio of the Total Labor Force (in %) of Netherlands in 1992 to that in 1997?
Provide a short and direct response. 0.97. What is the ratio of the Total Labor Force (in %) in New Caledonia in 1992 to that in 1997?
Provide a short and direct response. 0.96. What is the ratio of the Total Labor Force (in %) in Dominican Republic in 1992 to that in 1998?
Offer a terse response. 1.05. What is the ratio of the Total Labor Force (in %) in Greece in 1992 to that in 1998?
Keep it short and to the point. 0.92. What is the ratio of the Total Labor Force (in %) of Netherlands in 1992 to that in 1998?
Give a very brief answer. 0.93. What is the ratio of the Total Labor Force (in %) in New Caledonia in 1992 to that in 1998?
Give a very brief answer. 0.96. What is the ratio of the Total Labor Force (in %) of Greece in 1993 to that in 1994?
Offer a terse response. 1.05. What is the ratio of the Total Labor Force (in %) in New Caledonia in 1993 to that in 1994?
Keep it short and to the point. 0.99. What is the ratio of the Total Labor Force (in %) of Dominican Republic in 1993 to that in 1995?
Your answer should be very brief. 1.02. What is the ratio of the Total Labor Force (in %) of Greece in 1993 to that in 1995?
Your answer should be very brief. 1.04. What is the ratio of the Total Labor Force (in %) in Netherlands in 1993 to that in 1995?
Offer a terse response. 0.95. What is the ratio of the Total Labor Force (in %) in New Caledonia in 1993 to that in 1995?
Ensure brevity in your answer.  0.98. What is the ratio of the Total Labor Force (in %) in Dominican Republic in 1993 to that in 1996?
Your answer should be compact. 1.02. What is the ratio of the Total Labor Force (in %) in Greece in 1993 to that in 1996?
Offer a terse response. 1. What is the ratio of the Total Labor Force (in %) of Netherlands in 1993 to that in 1996?
Your answer should be very brief. 0.96. What is the ratio of the Total Labor Force (in %) of New Caledonia in 1993 to that in 1996?
Keep it short and to the point. 0.97. What is the ratio of the Total Labor Force (in %) of Greece in 1993 to that in 1997?
Offer a terse response. 1.04. What is the ratio of the Total Labor Force (in %) in Netherlands in 1993 to that in 1997?
Your answer should be very brief. 0.95. What is the ratio of the Total Labor Force (in %) of New Caledonia in 1993 to that in 1997?
Make the answer very short. 0.98. What is the ratio of the Total Labor Force (in %) in Dominican Republic in 1993 to that in 1998?
Make the answer very short. 1.04. What is the ratio of the Total Labor Force (in %) of Greece in 1993 to that in 1998?
Your answer should be compact. 0.94. What is the ratio of the Total Labor Force (in %) in Netherlands in 1993 to that in 1998?
Provide a short and direct response. 0.9. What is the ratio of the Total Labor Force (in %) of New Caledonia in 1993 to that in 1998?
Give a very brief answer. 0.98. What is the ratio of the Total Labor Force (in %) in Dominican Republic in 1994 to that in 1995?
Provide a succinct answer. 1.01. What is the ratio of the Total Labor Force (in %) in Greece in 1994 to that in 1995?
Keep it short and to the point. 0.99. What is the ratio of the Total Labor Force (in %) of Netherlands in 1994 to that in 1995?
Ensure brevity in your answer.  0.96. What is the ratio of the Total Labor Force (in %) of New Caledonia in 1994 to that in 1995?
Your response must be concise. 0.99. What is the ratio of the Total Labor Force (in %) of Dominican Republic in 1994 to that in 1996?
Provide a succinct answer. 1.02. What is the ratio of the Total Labor Force (in %) in Greece in 1994 to that in 1996?
Provide a short and direct response. 0.95. What is the ratio of the Total Labor Force (in %) of Netherlands in 1994 to that in 1996?
Provide a short and direct response. 0.97. What is the ratio of the Total Labor Force (in %) of New Caledonia in 1994 to that in 1996?
Provide a succinct answer. 0.99. What is the ratio of the Total Labor Force (in %) of Dominican Republic in 1994 to that in 1997?
Your answer should be compact. 1.03. What is the ratio of the Total Labor Force (in %) in Netherlands in 1994 to that in 1997?
Your response must be concise. 0.95. What is the ratio of the Total Labor Force (in %) in New Caledonia in 1994 to that in 1997?
Ensure brevity in your answer.  0.99. What is the ratio of the Total Labor Force (in %) in Dominican Republic in 1994 to that in 1998?
Keep it short and to the point. 1.04. What is the ratio of the Total Labor Force (in %) of Greece in 1994 to that in 1998?
Your response must be concise. 0.9. What is the ratio of the Total Labor Force (in %) in Netherlands in 1994 to that in 1998?
Your answer should be compact. 0.91. What is the ratio of the Total Labor Force (in %) of New Caledonia in 1994 to that in 1998?
Give a very brief answer. 0.99. What is the ratio of the Total Labor Force (in %) in Dominican Republic in 1995 to that in 1996?
Keep it short and to the point. 1.01. What is the ratio of the Total Labor Force (in %) of Greece in 1995 to that in 1996?
Provide a short and direct response. 0.96. What is the ratio of the Total Labor Force (in %) of Netherlands in 1995 to that in 1996?
Provide a short and direct response. 1.01. What is the ratio of the Total Labor Force (in %) of Dominican Republic in 1995 to that in 1997?
Your answer should be very brief. 1.02. What is the ratio of the Total Labor Force (in %) in Greece in 1995 to that in 1997?
Ensure brevity in your answer.  1. What is the ratio of the Total Labor Force (in %) of Netherlands in 1995 to that in 1997?
Provide a short and direct response. 0.99. What is the ratio of the Total Labor Force (in %) of New Caledonia in 1995 to that in 1997?
Your answer should be very brief. 1. What is the ratio of the Total Labor Force (in %) in Dominican Republic in 1995 to that in 1998?
Offer a very short reply. 1.03. What is the ratio of the Total Labor Force (in %) in Greece in 1995 to that in 1998?
Give a very brief answer. 0.9. What is the ratio of the Total Labor Force (in %) in Netherlands in 1995 to that in 1998?
Your answer should be compact. 0.95. What is the ratio of the Total Labor Force (in %) of Dominican Republic in 1996 to that in 1997?
Your response must be concise. 1.01. What is the ratio of the Total Labor Force (in %) of Greece in 1996 to that in 1997?
Give a very brief answer. 1.04. What is the ratio of the Total Labor Force (in %) in Netherlands in 1996 to that in 1997?
Make the answer very short. 0.98. What is the ratio of the Total Labor Force (in %) of Dominican Republic in 1996 to that in 1998?
Offer a terse response. 1.02. What is the ratio of the Total Labor Force (in %) in Greece in 1996 to that in 1998?
Give a very brief answer. 0.94. What is the ratio of the Total Labor Force (in %) of Netherlands in 1996 to that in 1998?
Ensure brevity in your answer.  0.94. What is the ratio of the Total Labor Force (in %) of Greece in 1997 to that in 1998?
Your response must be concise. 0.9. What is the ratio of the Total Labor Force (in %) in Netherlands in 1997 to that in 1998?
Your response must be concise. 0.96. What is the ratio of the Total Labor Force (in %) of New Caledonia in 1997 to that in 1998?
Your response must be concise. 1. What is the difference between the highest and the lowest Total Labor Force (in %) of Greece?
Your answer should be compact. 3.9. What is the difference between the highest and the lowest Total Labor Force (in %) of Netherlands?
Provide a succinct answer. 6.2. 